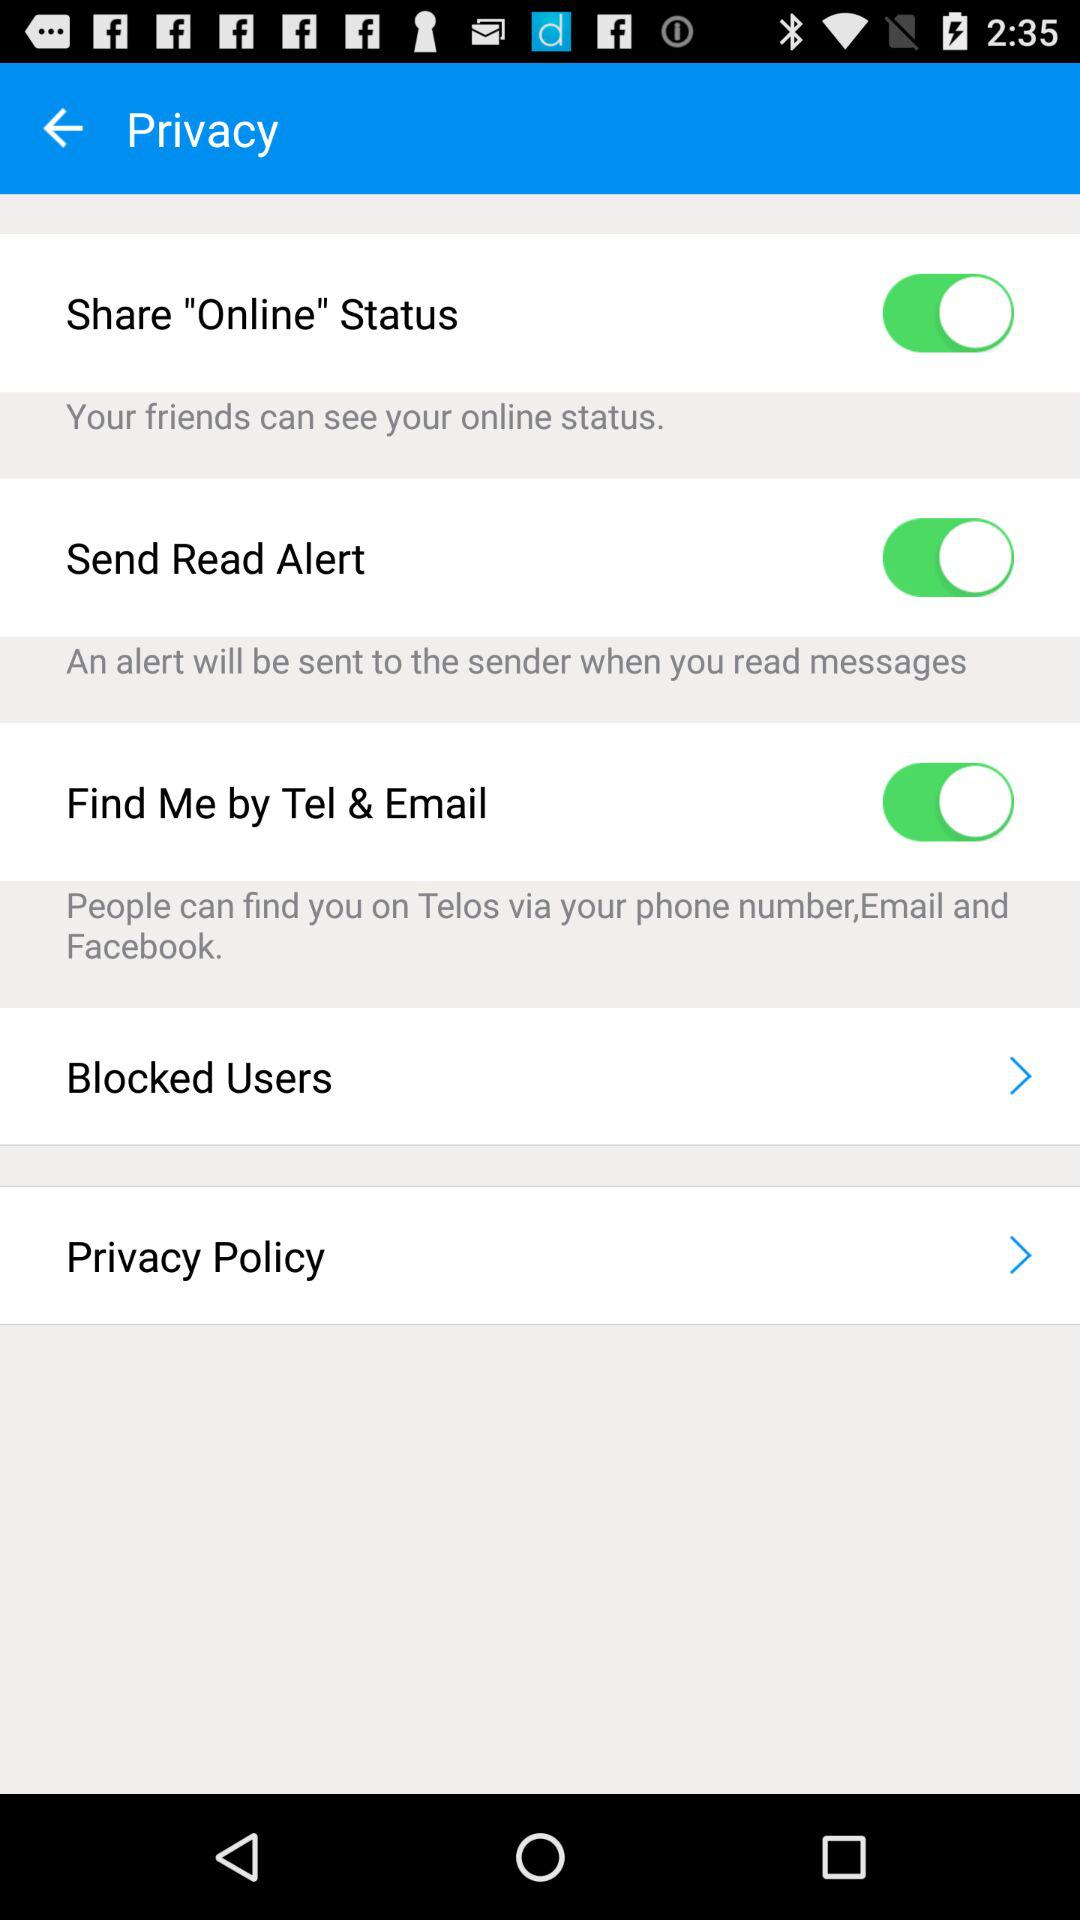What is the current status of "Find Me by Tel & Email"? The current status is "on". 